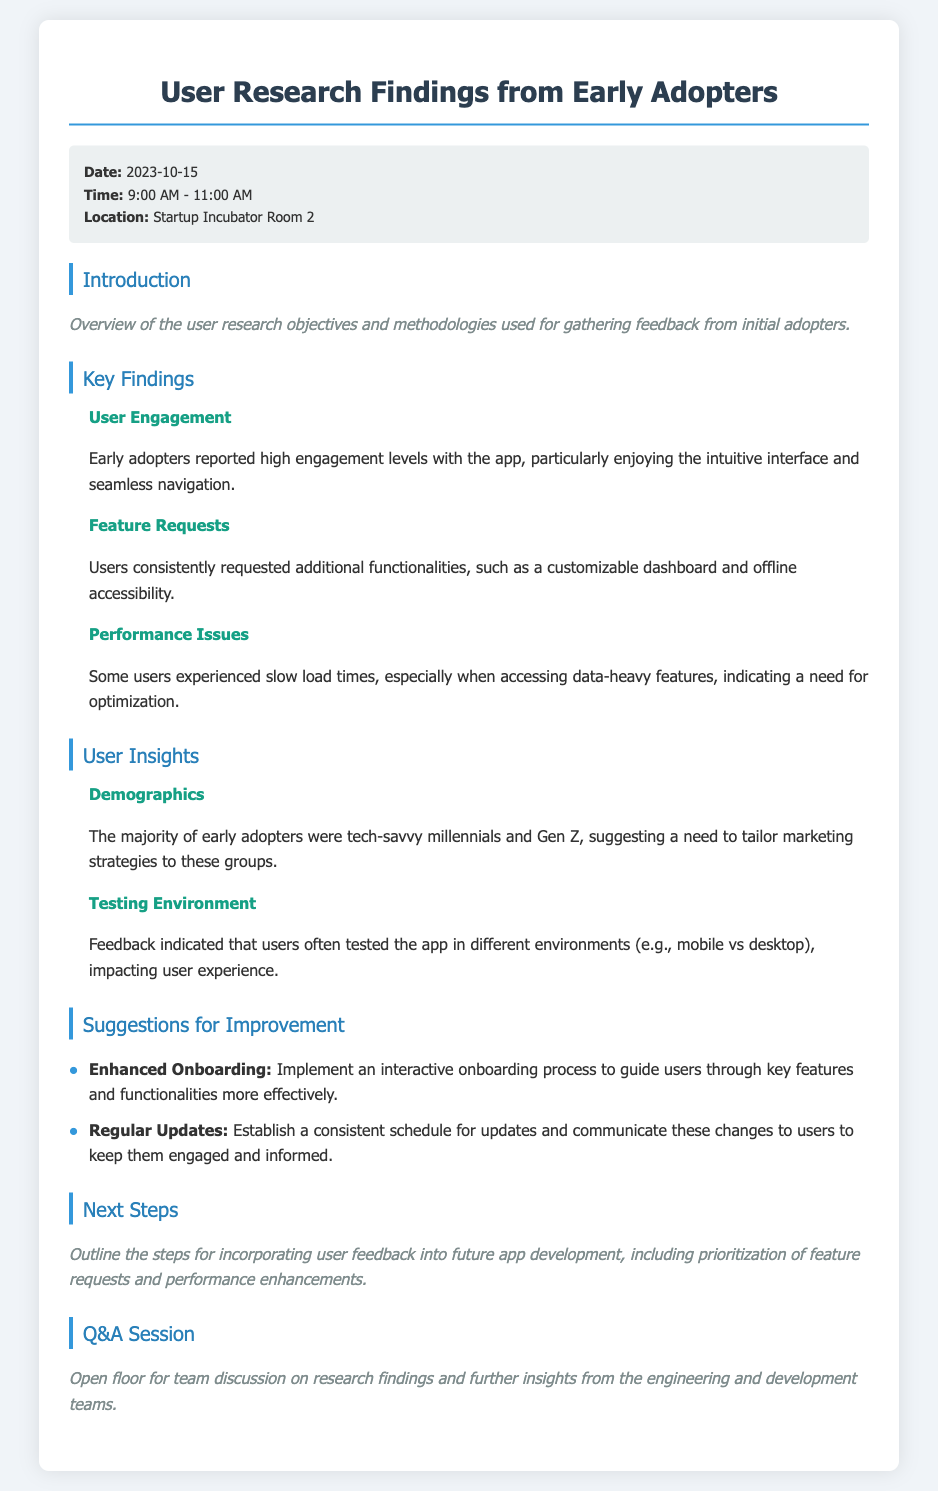What date was the user research meeting held? The date of the user research meeting is explicitly stated in the document.
Answer: 2023-10-15 What is one of the key findings regarding user engagement? The document highlights specific aspects of user engagement reported by early adopters.
Answer: High engagement levels What suggestions were made for improving onboarding? The document lists detailed recommendations for enhancing user experience, including onboarding.
Answer: Enhanced Onboarding Which demographic was primarily represented among early adopters? The document discusses the characteristics of the user group that participated in research.
Answer: Tech-savvy millennials and Gen Z What performance issue did some users experience? The document notes specific problems users faced with the app performance during feedback sessions.
Answer: Slow load times How long did the meeting last? The duration of the meeting can be inferred from the time stated in the document, indicating the start and end.
Answer: 2 hours What is one of the next steps outlined in the document? The document specifies steps that will be taken after gathering feedback.
Answer: Incorporating user feedback What environment did users often test the app in? The document provides insights into the testing surroundings that influenced user experience.
Answer: Mobile vs desktop What is the purpose of the Q&A session? The document describes the intent of the session following the findings presentation.
Answer: Team discussion on research findings 